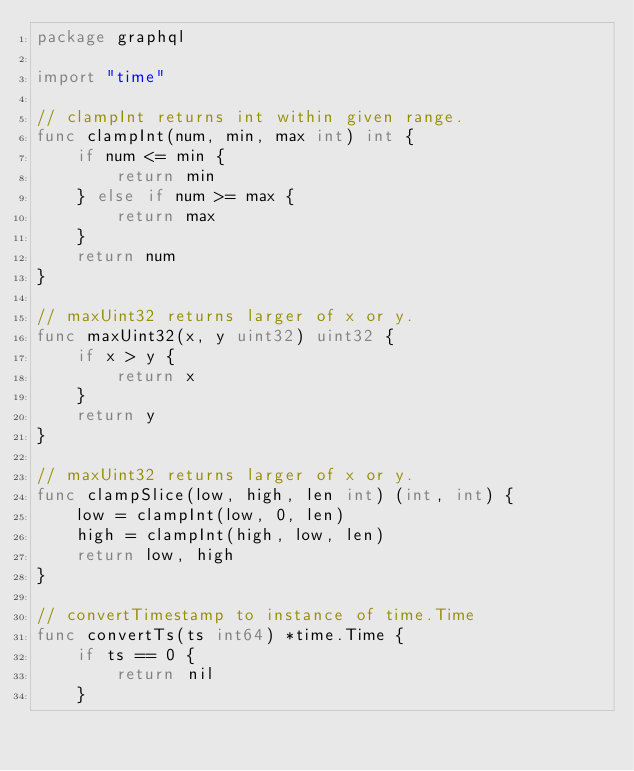Convert code to text. <code><loc_0><loc_0><loc_500><loc_500><_Go_>package graphql

import "time"

// clampInt returns int within given range.
func clampInt(num, min, max int) int {
	if num <= min {
		return min
	} else if num >= max {
		return max
	}
	return num
}

// maxUint32 returns larger of x or y.
func maxUint32(x, y uint32) uint32 {
	if x > y {
		return x
	}
	return y
}

// maxUint32 returns larger of x or y.
func clampSlice(low, high, len int) (int, int) {
	low = clampInt(low, 0, len)
	high = clampInt(high, low, len)
	return low, high
}

// convertTimestamp to instance of time.Time
func convertTs(ts int64) *time.Time {
	if ts == 0 {
		return nil
	}</code> 